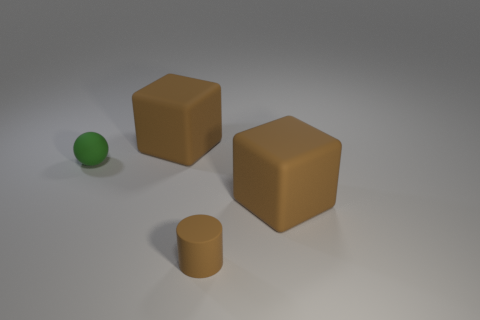Subtract all brown blocks. How many were subtracted if there are1brown blocks left? 1 Add 3 small blue cubes. How many objects exist? 7 Subtract all balls. How many objects are left? 3 Add 3 big brown cubes. How many big brown cubes are left? 5 Add 4 brown matte objects. How many brown matte objects exist? 7 Subtract 0 cyan cubes. How many objects are left? 4 Subtract all small blue rubber cylinders. Subtract all brown cylinders. How many objects are left? 3 